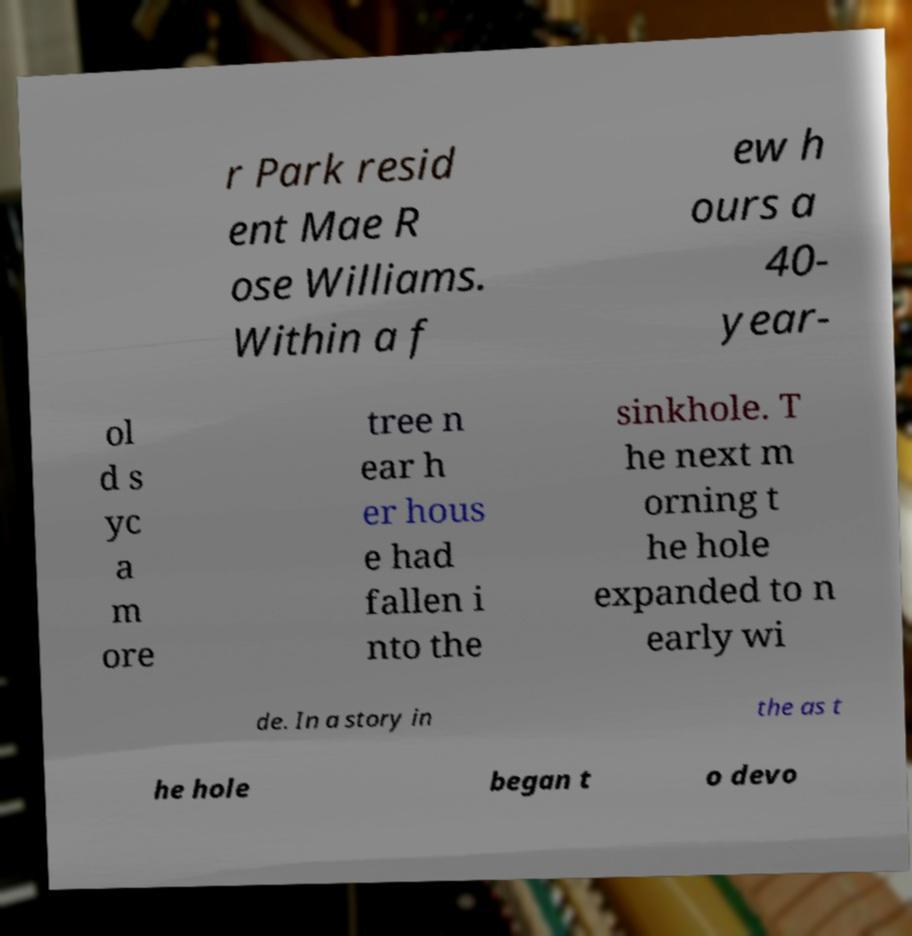Please read and relay the text visible in this image. What does it say? r Park resid ent Mae R ose Williams. Within a f ew h ours a 40- year- ol d s yc a m ore tree n ear h er hous e had fallen i nto the sinkhole. T he next m orning t he hole expanded to n early wi de. In a story in the as t he hole began t o devo 